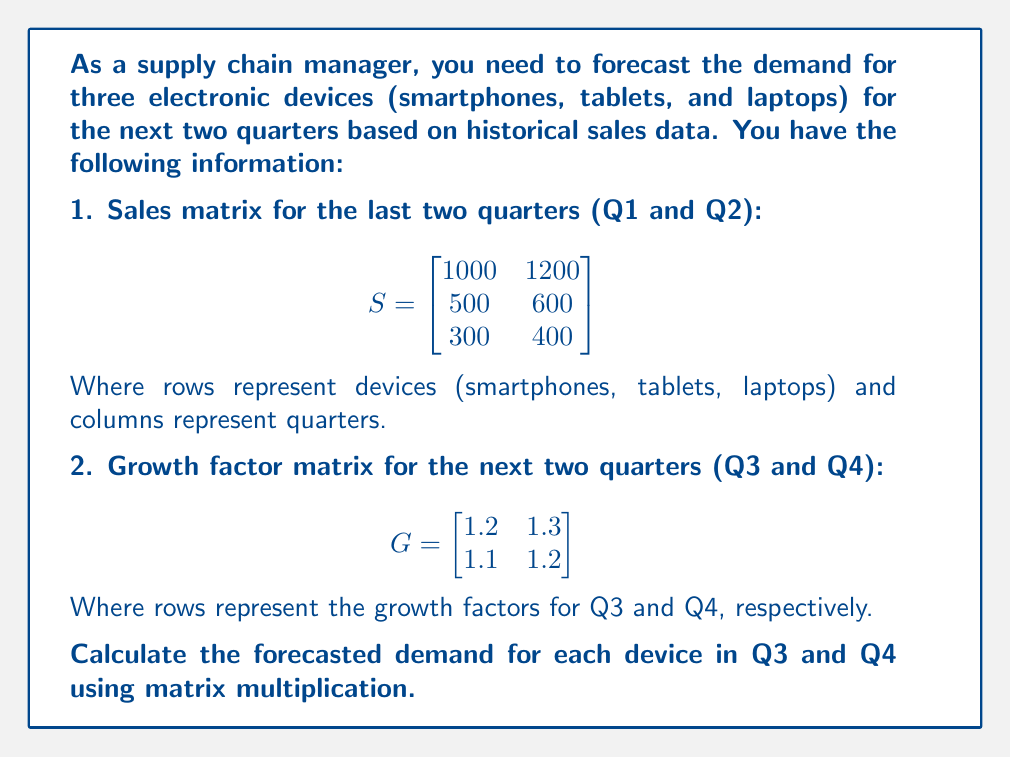Could you help me with this problem? To solve this problem, we need to multiply the sales matrix (S) by the growth factor matrix (G). This multiplication will give us the forecasted demand for each device in Q3 and Q4.

Step 1: Verify that matrix multiplication is possible.
The number of columns in S (2) matches the number of rows in G (2), so multiplication is possible.

Step 2: Perform matrix multiplication S × G.
The resulting matrix will have dimensions 3×2, where rows represent devices and columns represent Q3 and Q4 forecasts.

$$\begin{bmatrix}
1000 & 1200 \\
500 & 600 \\
300 & 400
\end{bmatrix} \times
\begin{bmatrix}
1.2 & 1.3 \\
1.1 & 1.2 \\
\end{bmatrix}$$

Step 3: Calculate each element of the resulting matrix.

For smartphones (Q3): $1000 \times 1.2 + 1200 \times 1.1 = 2520$
For smartphones (Q4): $1000 \times 1.3 + 1200 \times 1.2 = 2740$

For tablets (Q3): $500 \times 1.2 + 600 \times 1.1 = 1260$
For tablets (Q4): $500 \times 1.3 + 600 \times 1.2 = 1370$

For laptops (Q3): $300 \times 1.2 + 400 \times 1.1 = 800$
For laptops (Q4): $300 \times 1.3 + 400 \times 1.2 = 870$

Step 4: Write the final forecasted demand matrix.

$$F = \begin{bmatrix}
2520 & 2740 \\
1260 & 1370 \\
800 & 870
\end{bmatrix}$$

This matrix represents the forecasted demand for smartphones, tablets, and laptops in Q3 and Q4, respectively.
Answer: $$\begin{bmatrix}
2520 & 2740 \\
1260 & 1370 \\
800 & 870
\end{bmatrix}$$ 